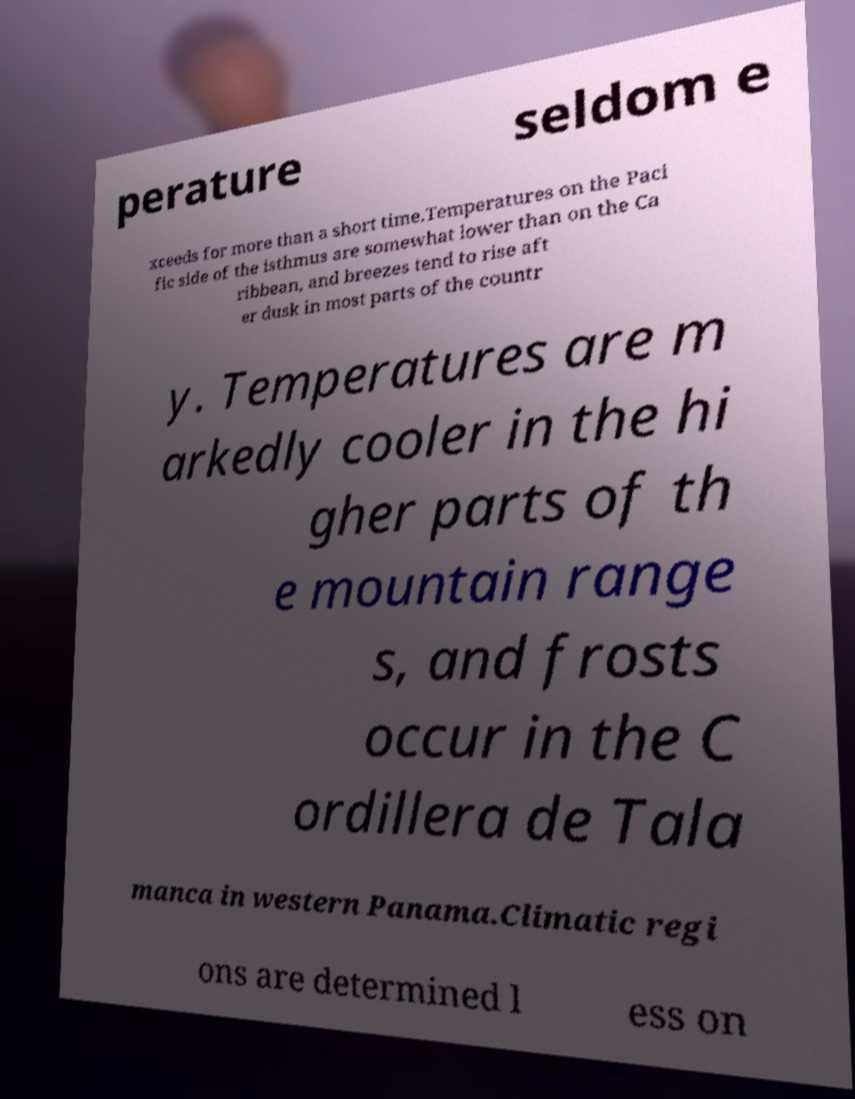Could you extract and type out the text from this image? perature seldom e xceeds for more than a short time.Temperatures on the Paci fic side of the isthmus are somewhat lower than on the Ca ribbean, and breezes tend to rise aft er dusk in most parts of the countr y. Temperatures are m arkedly cooler in the hi gher parts of th e mountain range s, and frosts occur in the C ordillera de Tala manca in western Panama.Climatic regi ons are determined l ess on 